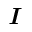<formula> <loc_0><loc_0><loc_500><loc_500>I</formula> 